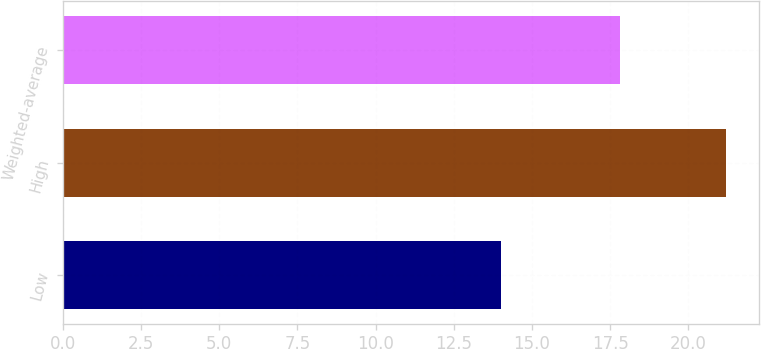Convert chart to OTSL. <chart><loc_0><loc_0><loc_500><loc_500><bar_chart><fcel>Low<fcel>High<fcel>Weighted-average<nl><fcel>14<fcel>21.2<fcel>17.8<nl></chart> 